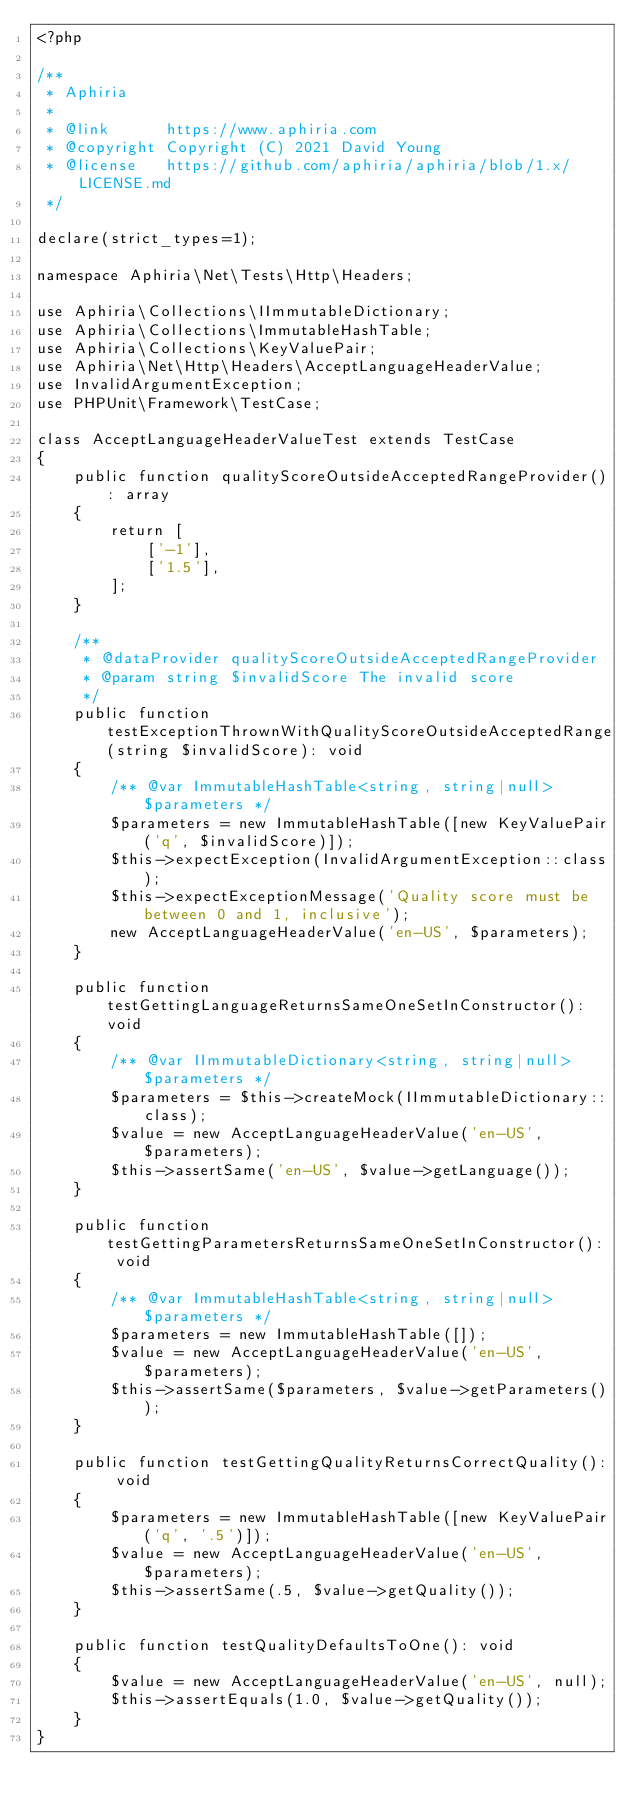<code> <loc_0><loc_0><loc_500><loc_500><_PHP_><?php

/**
 * Aphiria
 *
 * @link      https://www.aphiria.com
 * @copyright Copyright (C) 2021 David Young
 * @license   https://github.com/aphiria/aphiria/blob/1.x/LICENSE.md
 */

declare(strict_types=1);

namespace Aphiria\Net\Tests\Http\Headers;

use Aphiria\Collections\IImmutableDictionary;
use Aphiria\Collections\ImmutableHashTable;
use Aphiria\Collections\KeyValuePair;
use Aphiria\Net\Http\Headers\AcceptLanguageHeaderValue;
use InvalidArgumentException;
use PHPUnit\Framework\TestCase;

class AcceptLanguageHeaderValueTest extends TestCase
{
    public function qualityScoreOutsideAcceptedRangeProvider(): array
    {
        return [
            ['-1'],
            ['1.5'],
        ];
    }

    /**
     * @dataProvider qualityScoreOutsideAcceptedRangeProvider
     * @param string $invalidScore The invalid score
     */
    public function testExceptionThrownWithQualityScoreOutsideAcceptedRange(string $invalidScore): void
    {
        /** @var ImmutableHashTable<string, string|null> $parameters */
        $parameters = new ImmutableHashTable([new KeyValuePair('q', $invalidScore)]);
        $this->expectException(InvalidArgumentException::class);
        $this->expectExceptionMessage('Quality score must be between 0 and 1, inclusive');
        new AcceptLanguageHeaderValue('en-US', $parameters);
    }

    public function testGettingLanguageReturnsSameOneSetInConstructor(): void
    {
        /** @var IImmutableDictionary<string, string|null> $parameters */
        $parameters = $this->createMock(IImmutableDictionary::class);
        $value = new AcceptLanguageHeaderValue('en-US', $parameters);
        $this->assertSame('en-US', $value->getLanguage());
    }

    public function testGettingParametersReturnsSameOneSetInConstructor(): void
    {
        /** @var ImmutableHashTable<string, string|null> $parameters */
        $parameters = new ImmutableHashTable([]);
        $value = new AcceptLanguageHeaderValue('en-US', $parameters);
        $this->assertSame($parameters, $value->getParameters());
    }

    public function testGettingQualityReturnsCorrectQuality(): void
    {
        $parameters = new ImmutableHashTable([new KeyValuePair('q', '.5')]);
        $value = new AcceptLanguageHeaderValue('en-US', $parameters);
        $this->assertSame(.5, $value->getQuality());
    }

    public function testQualityDefaultsToOne(): void
    {
        $value = new AcceptLanguageHeaderValue('en-US', null);
        $this->assertEquals(1.0, $value->getQuality());
    }
}
</code> 